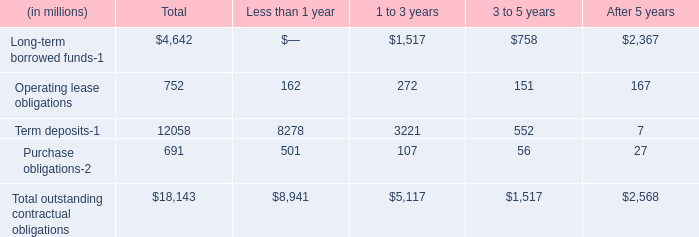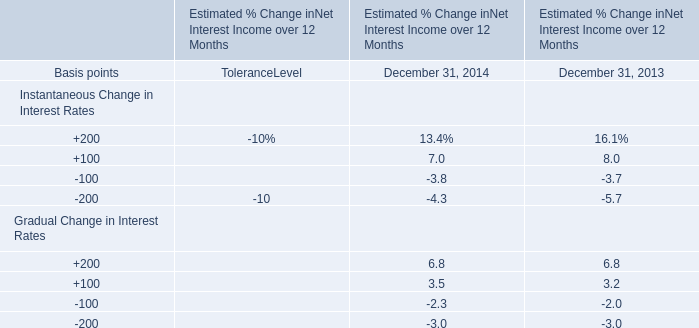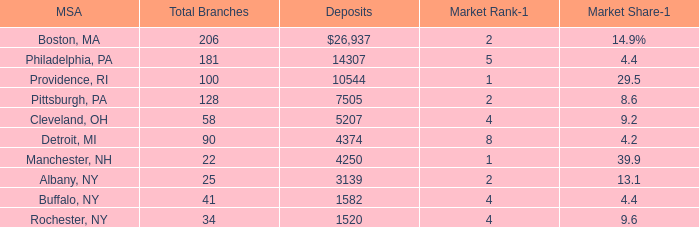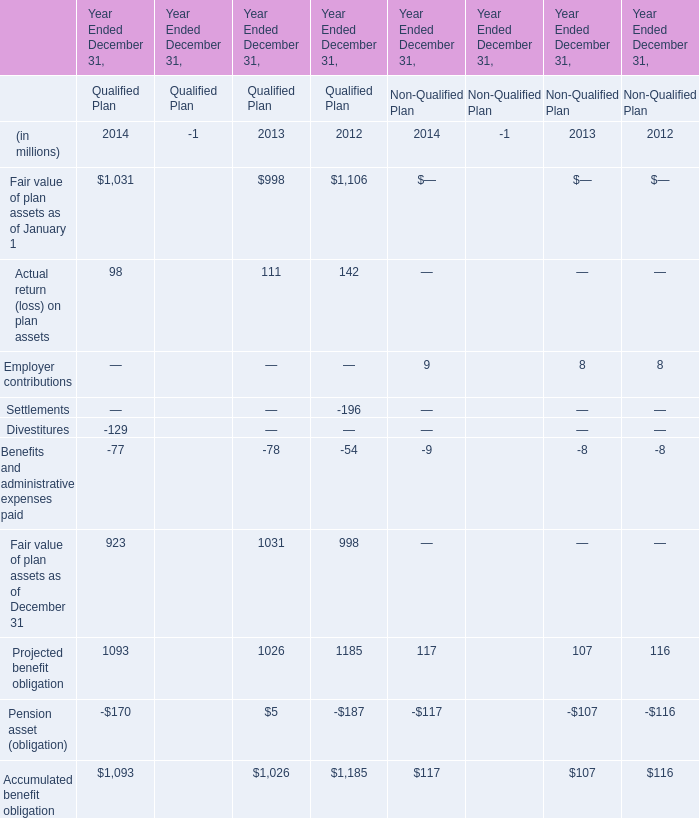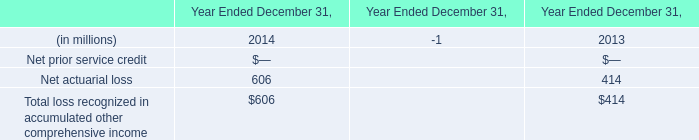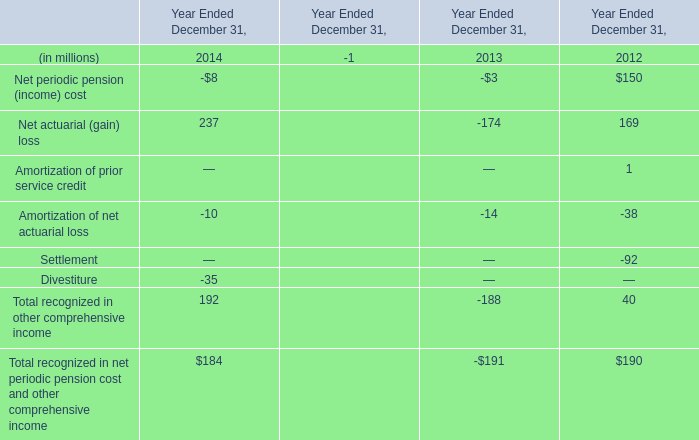What is the total amount of Rochester, NY of Deposits, and Term deposits of Less than 1 year ? 
Computations: (1520.0 + 8278.0)
Answer: 9798.0. 